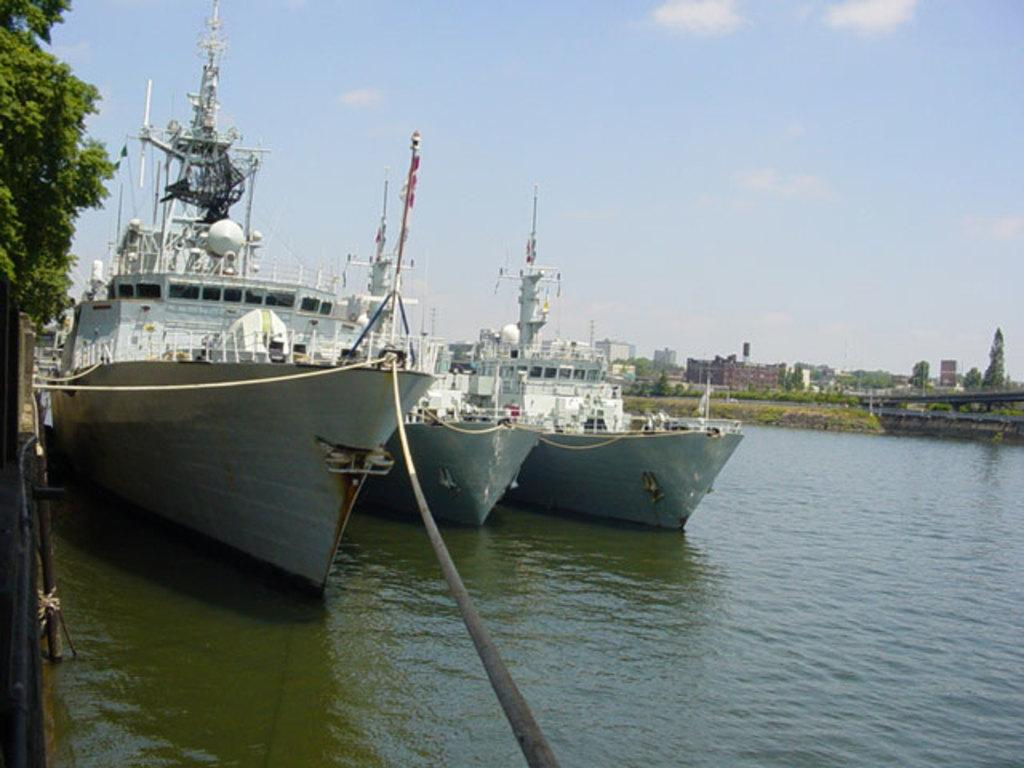What is present on the river in the image? There are ships on the river in the image. What object can be seen near the ships? There is a rope visible in the image. What structures are present in the image? There are buildings in the image. What type of vegetation is present in the image? There are trees in the image. What part of the natural environment is visible in the image? The sky is visible in the image. Can you tell me how many snails are crawling on the buildings in the image? There are no snails present in the image; the buildings are not depicted with any snails. What type of lizards can be seen basking in the sun on the trees in the image? There are no lizards present in the image; the trees do not have any lizards basking in the sun. 